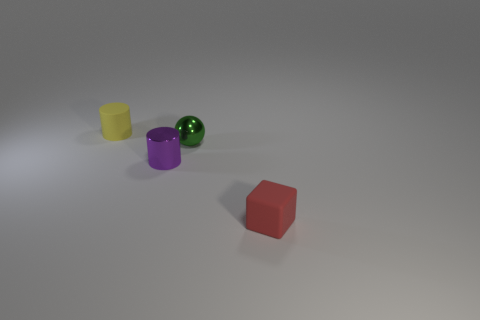Add 1 big brown rubber balls. How many objects exist? 5 Subtract all balls. How many objects are left? 3 Subtract 0 blue blocks. How many objects are left? 4 Subtract all large green rubber objects. Subtract all rubber things. How many objects are left? 2 Add 3 tiny matte cubes. How many tiny matte cubes are left? 4 Add 2 small metallic things. How many small metallic things exist? 4 